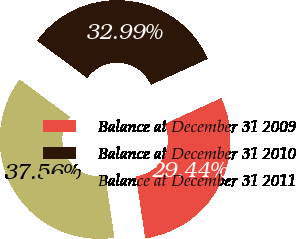<chart> <loc_0><loc_0><loc_500><loc_500><pie_chart><fcel>Balance at December 31 2009<fcel>Balance at December 31 2010<fcel>Balance at December 31 2011<nl><fcel>29.44%<fcel>32.99%<fcel>37.56%<nl></chart> 